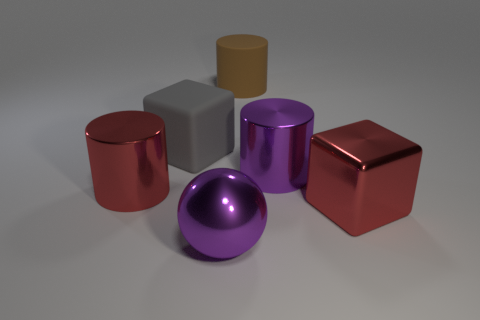Subtract all metal cylinders. How many cylinders are left? 1 Add 2 big gray matte cubes. How many objects exist? 8 Subtract all spheres. How many objects are left? 5 Subtract all small yellow objects. Subtract all large gray rubber things. How many objects are left? 5 Add 4 rubber blocks. How many rubber blocks are left? 5 Add 5 big gray rubber cubes. How many big gray rubber cubes exist? 6 Subtract 0 gray cylinders. How many objects are left? 6 